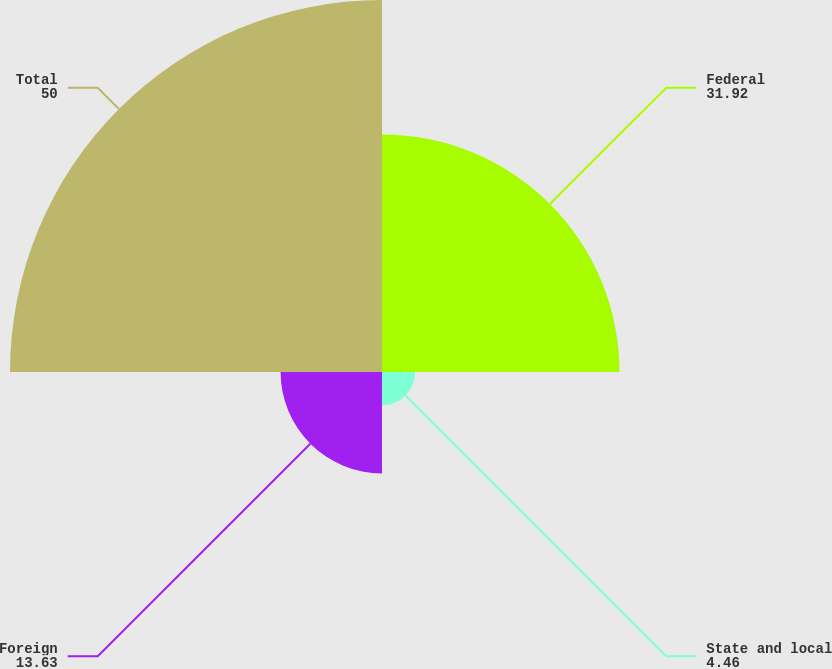Convert chart. <chart><loc_0><loc_0><loc_500><loc_500><pie_chart><fcel>Federal<fcel>State and local<fcel>Foreign<fcel>Total<nl><fcel>31.92%<fcel>4.46%<fcel>13.63%<fcel>50.0%<nl></chart> 